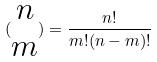<formula> <loc_0><loc_0><loc_500><loc_500>( \begin{matrix} n \\ m \end{matrix} ) = \frac { n ! } { m ! ( n - m ) ! }</formula> 